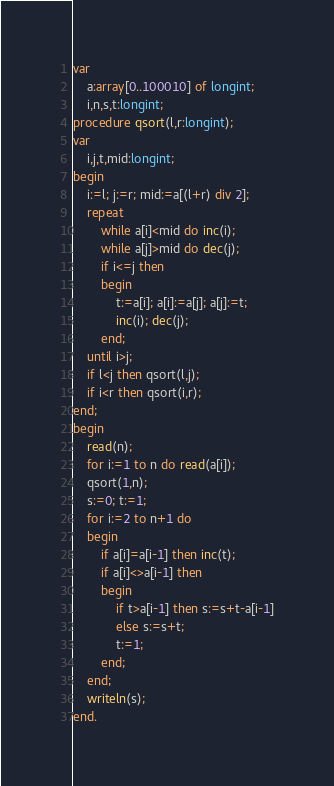Convert code to text. <code><loc_0><loc_0><loc_500><loc_500><_Pascal_>var
    a:array[0..100010] of longint;
    i,n,s,t:longint;
procedure qsort(l,r:longint);
var
    i,j,t,mid:longint;
begin
    i:=l; j:=r; mid:=a[(l+r) div 2];
    repeat
        while a[i]<mid do inc(i);
        while a[j]>mid do dec(j);
        if i<=j then
        begin
            t:=a[i]; a[i]:=a[j]; a[j]:=t;
            inc(i); dec(j);
        end;
    until i>j;
    if l<j then qsort(l,j);
    if i<r then qsort(i,r);
end;
begin
    read(n);
    for i:=1 to n do read(a[i]);
    qsort(1,n);
    s:=0; t:=1;
    for i:=2 to n+1 do
    begin
        if a[i]=a[i-1] then inc(t);
        if a[i]<>a[i-1] then
        begin
            if t>a[i-1] then s:=s+t-a[i-1]
            else s:=s+t;
            t:=1;
        end;
    end;
    writeln(s);
end.</code> 